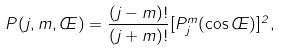Convert formula to latex. <formula><loc_0><loc_0><loc_500><loc_500>P ( j , m , \phi ) = \frac { ( j - m ) ! } { ( j + m ) ! } [ P ^ { m } _ { j } ( \cos \phi ) ] ^ { 2 } ,</formula> 